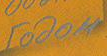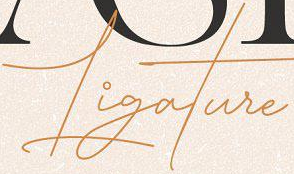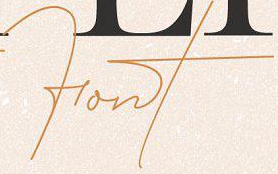Read the text from these images in sequence, separated by a semicolon. rodom; Ligature; Font 